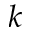Convert formula to latex. <formula><loc_0><loc_0><loc_500><loc_500>k</formula> 